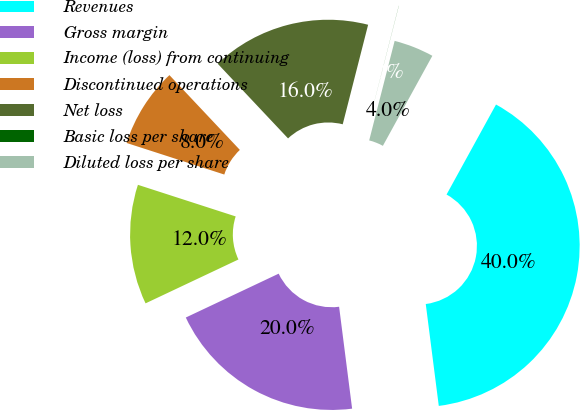Convert chart. <chart><loc_0><loc_0><loc_500><loc_500><pie_chart><fcel>Revenues<fcel>Gross margin<fcel>Income (loss) from continuing<fcel>Discontinued operations<fcel>Net loss<fcel>Basic loss per share<fcel>Diluted loss per share<nl><fcel>39.98%<fcel>20.0%<fcel>12.0%<fcel>8.0%<fcel>16.0%<fcel>0.01%<fcel>4.01%<nl></chart> 